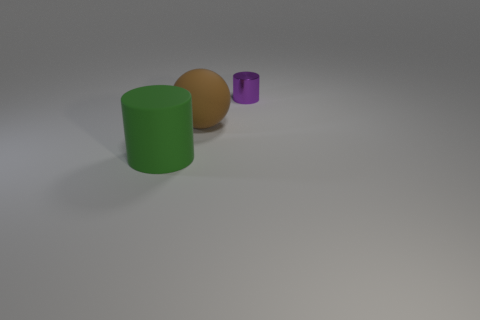Add 1 tiny red spheres. How many objects exist? 4 Subtract all spheres. How many objects are left? 2 Add 3 green rubber objects. How many green rubber objects are left? 4 Add 3 big brown spheres. How many big brown spheres exist? 4 Subtract 0 blue cubes. How many objects are left? 3 Subtract all small purple cylinders. Subtract all brown matte balls. How many objects are left? 1 